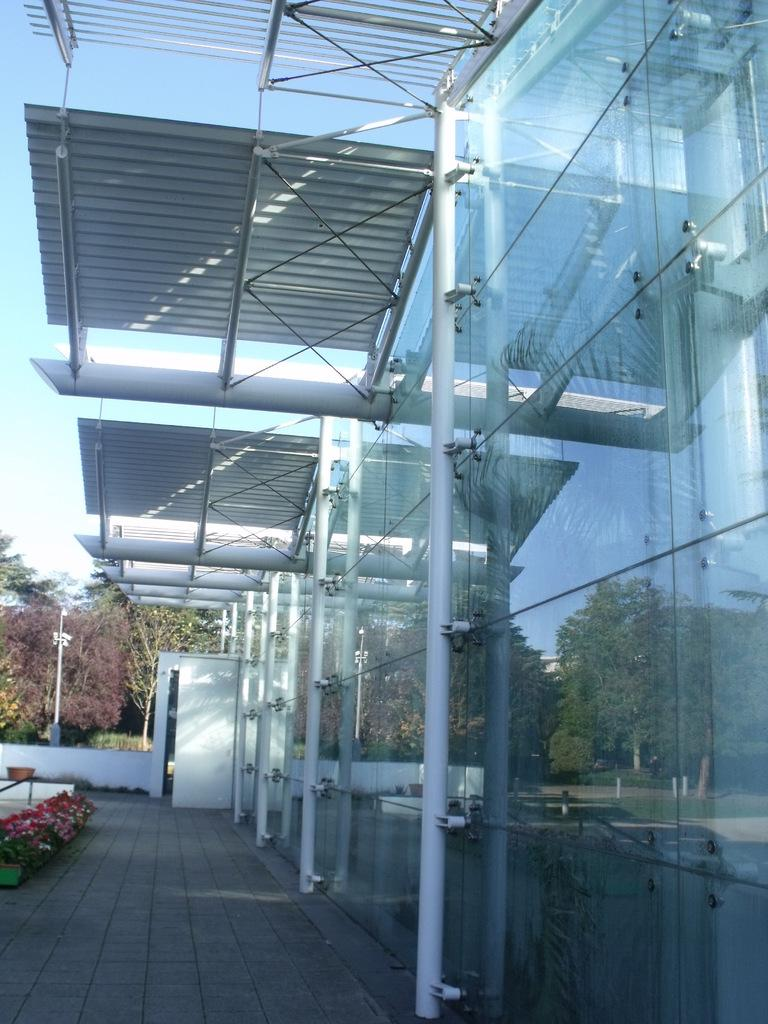What objects can be seen in the image? There are rods, glass, and plants in the image. What can be seen through the glass in the image? Trees and the sky can be seen through the glass in the image. What is visible in the background of the image? Trees, a pole, and the sky are visible in the background of the image. What type of vest is being worn by the plant in the image? There is no vest present in the image, as the main subject is a plant and plants do not wear clothing. 